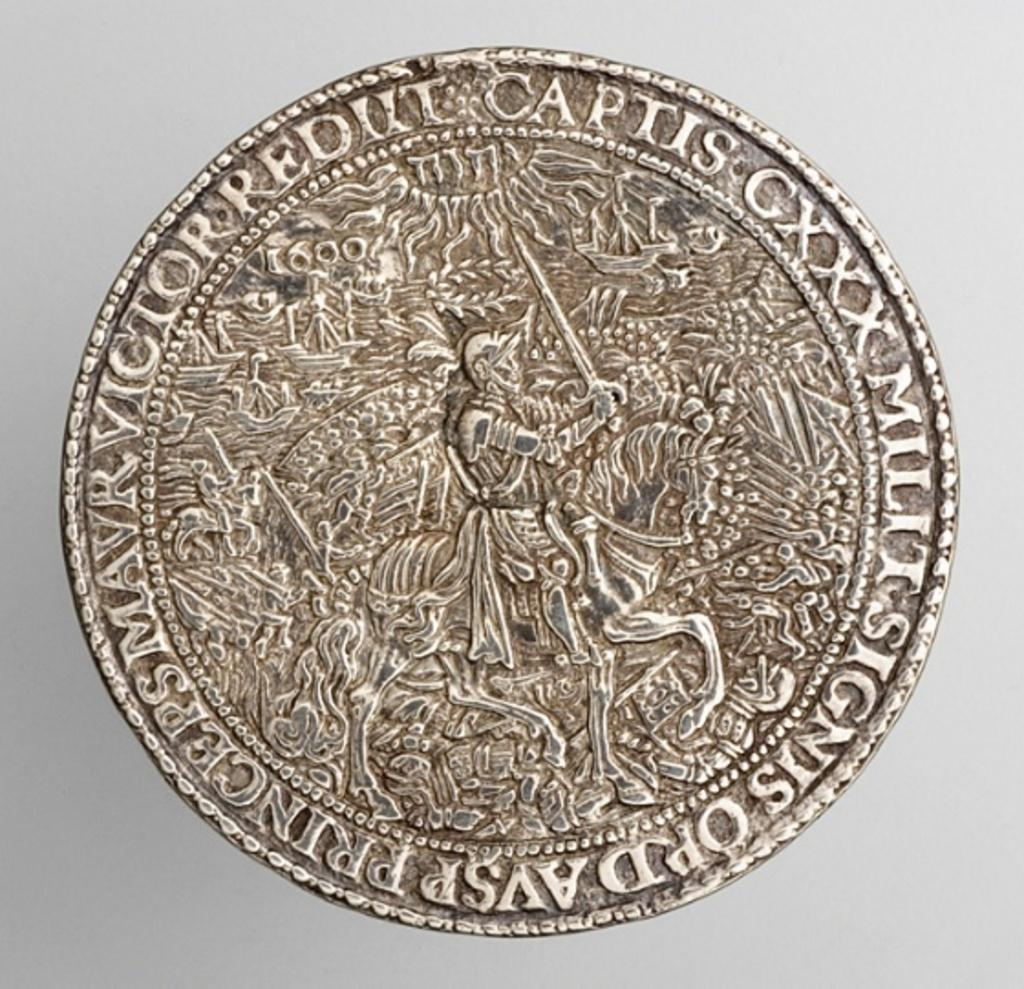<image>
Provide a brief description of the given image. A silver coin with the name Victor Redut Captis. 